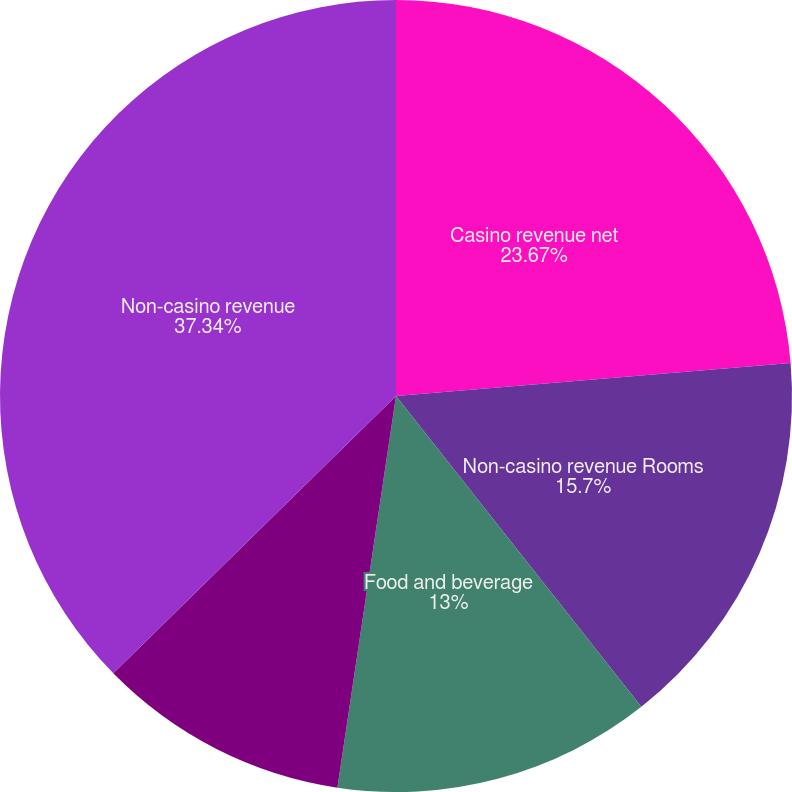Convert chart. <chart><loc_0><loc_0><loc_500><loc_500><pie_chart><fcel>Casino revenue net<fcel>Non-casino revenue Rooms<fcel>Food and beverage<fcel>Entertainment retail and other<fcel>Non-casino revenue<nl><fcel>23.67%<fcel>15.7%<fcel>13.0%<fcel>10.29%<fcel>37.35%<nl></chart> 